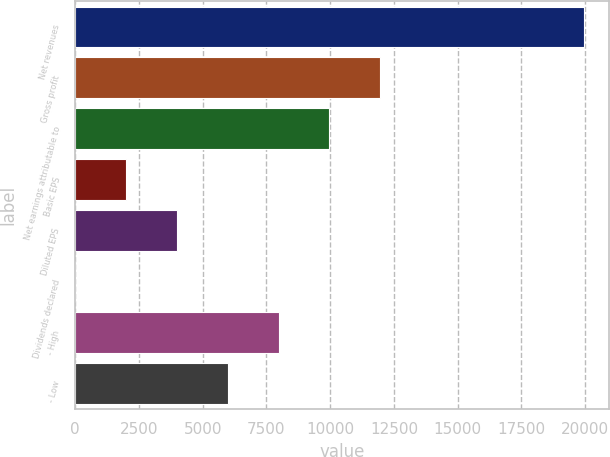Convert chart. <chart><loc_0><loc_0><loc_500><loc_500><bar_chart><fcel>Net revenues<fcel>Gross profit<fcel>Net earnings attributable to<fcel>Basic EPS<fcel>Diluted EPS<fcel>Dividends declared<fcel>- High<fcel>- Low<nl><fcel>19941<fcel>11965<fcel>9971<fcel>1995<fcel>3989<fcel>1<fcel>7977<fcel>5983<nl></chart> 